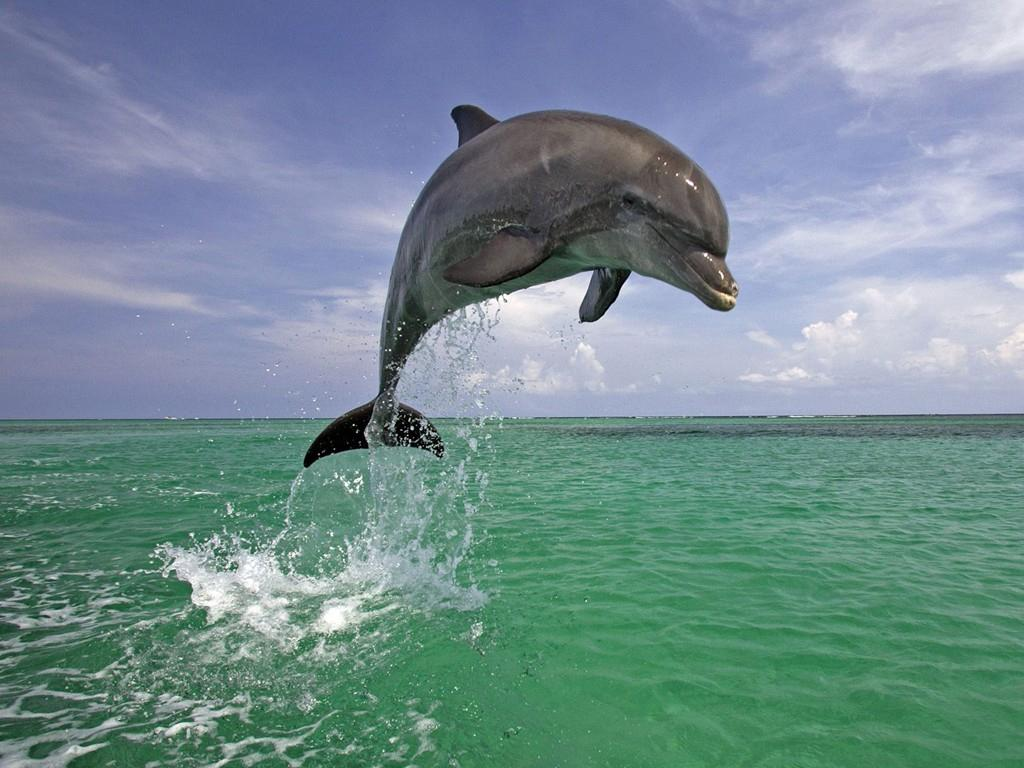What natural elements are present in the image? The image contains the sky and water. Can you describe the location of the dolphin in the image? There is a dolphin in the air in the image. What type of airplane can be seen flying in the sky in the image? There is no airplane present in the image; it features a dolphin in the air. What kind of joke is being told by the dolphin in the image? There is no joke being told by the dolphin in the image, as it is a photograph and not a scene with dialogue. 